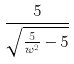<formula> <loc_0><loc_0><loc_500><loc_500>\frac { 5 } { \sqrt { \frac { 5 } { w ^ { 2 } } - 5 } }</formula> 